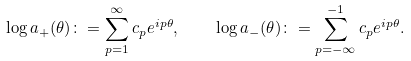Convert formula to latex. <formula><loc_0><loc_0><loc_500><loc_500>\log a _ { + } ( \theta ) \colon = \sum _ { p = 1 } ^ { \infty } c _ { p } e ^ { i p \theta } , \quad \log a _ { - } ( \theta ) \colon = \sum _ { p = - \infty } ^ { - 1 } c _ { p } e ^ { i p \theta } .</formula> 